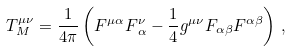Convert formula to latex. <formula><loc_0><loc_0><loc_500><loc_500>T _ { M } ^ { \mu \nu } = \frac { 1 } { 4 \pi } \left ( F ^ { \mu \alpha } F ^ { \nu } _ { \, \alpha } - \frac { 1 } { 4 } g ^ { \mu \nu } F _ { \alpha \beta } F ^ { \alpha \beta } \right ) \, ,</formula> 